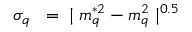<formula> <loc_0><loc_0><loc_500><loc_500>\sigma _ { q } \, = \, | m _ { q } ^ { * 2 } - m _ { q } ^ { 2 } | ^ { 0 . 5 }</formula> 